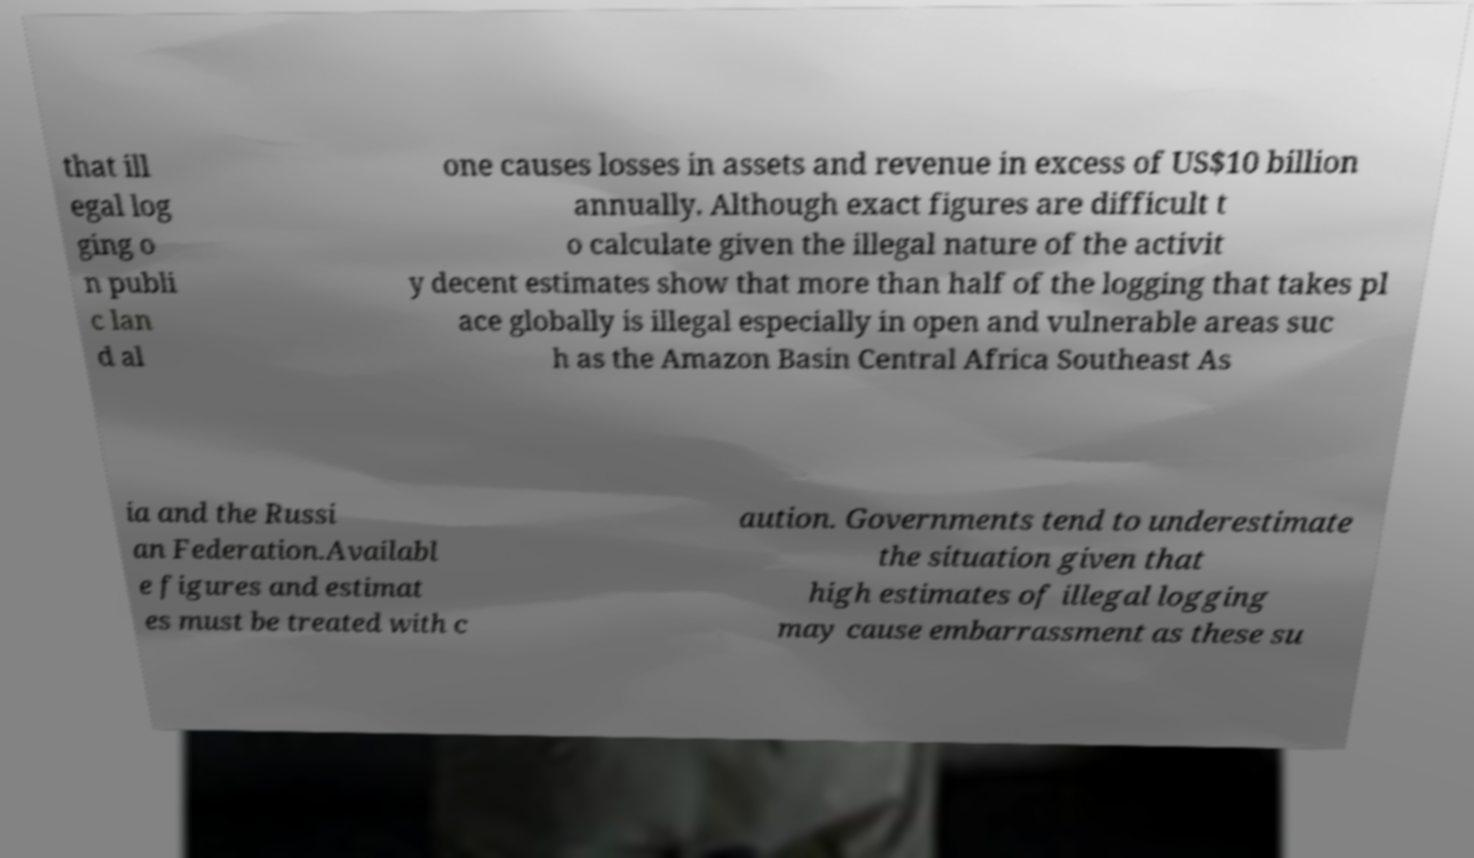What messages or text are displayed in this image? I need them in a readable, typed format. that ill egal log ging o n publi c lan d al one causes losses in assets and revenue in excess of US$10 billion annually. Although exact figures are difficult t o calculate given the illegal nature of the activit y decent estimates show that more than half of the logging that takes pl ace globally is illegal especially in open and vulnerable areas suc h as the Amazon Basin Central Africa Southeast As ia and the Russi an Federation.Availabl e figures and estimat es must be treated with c aution. Governments tend to underestimate the situation given that high estimates of illegal logging may cause embarrassment as these su 